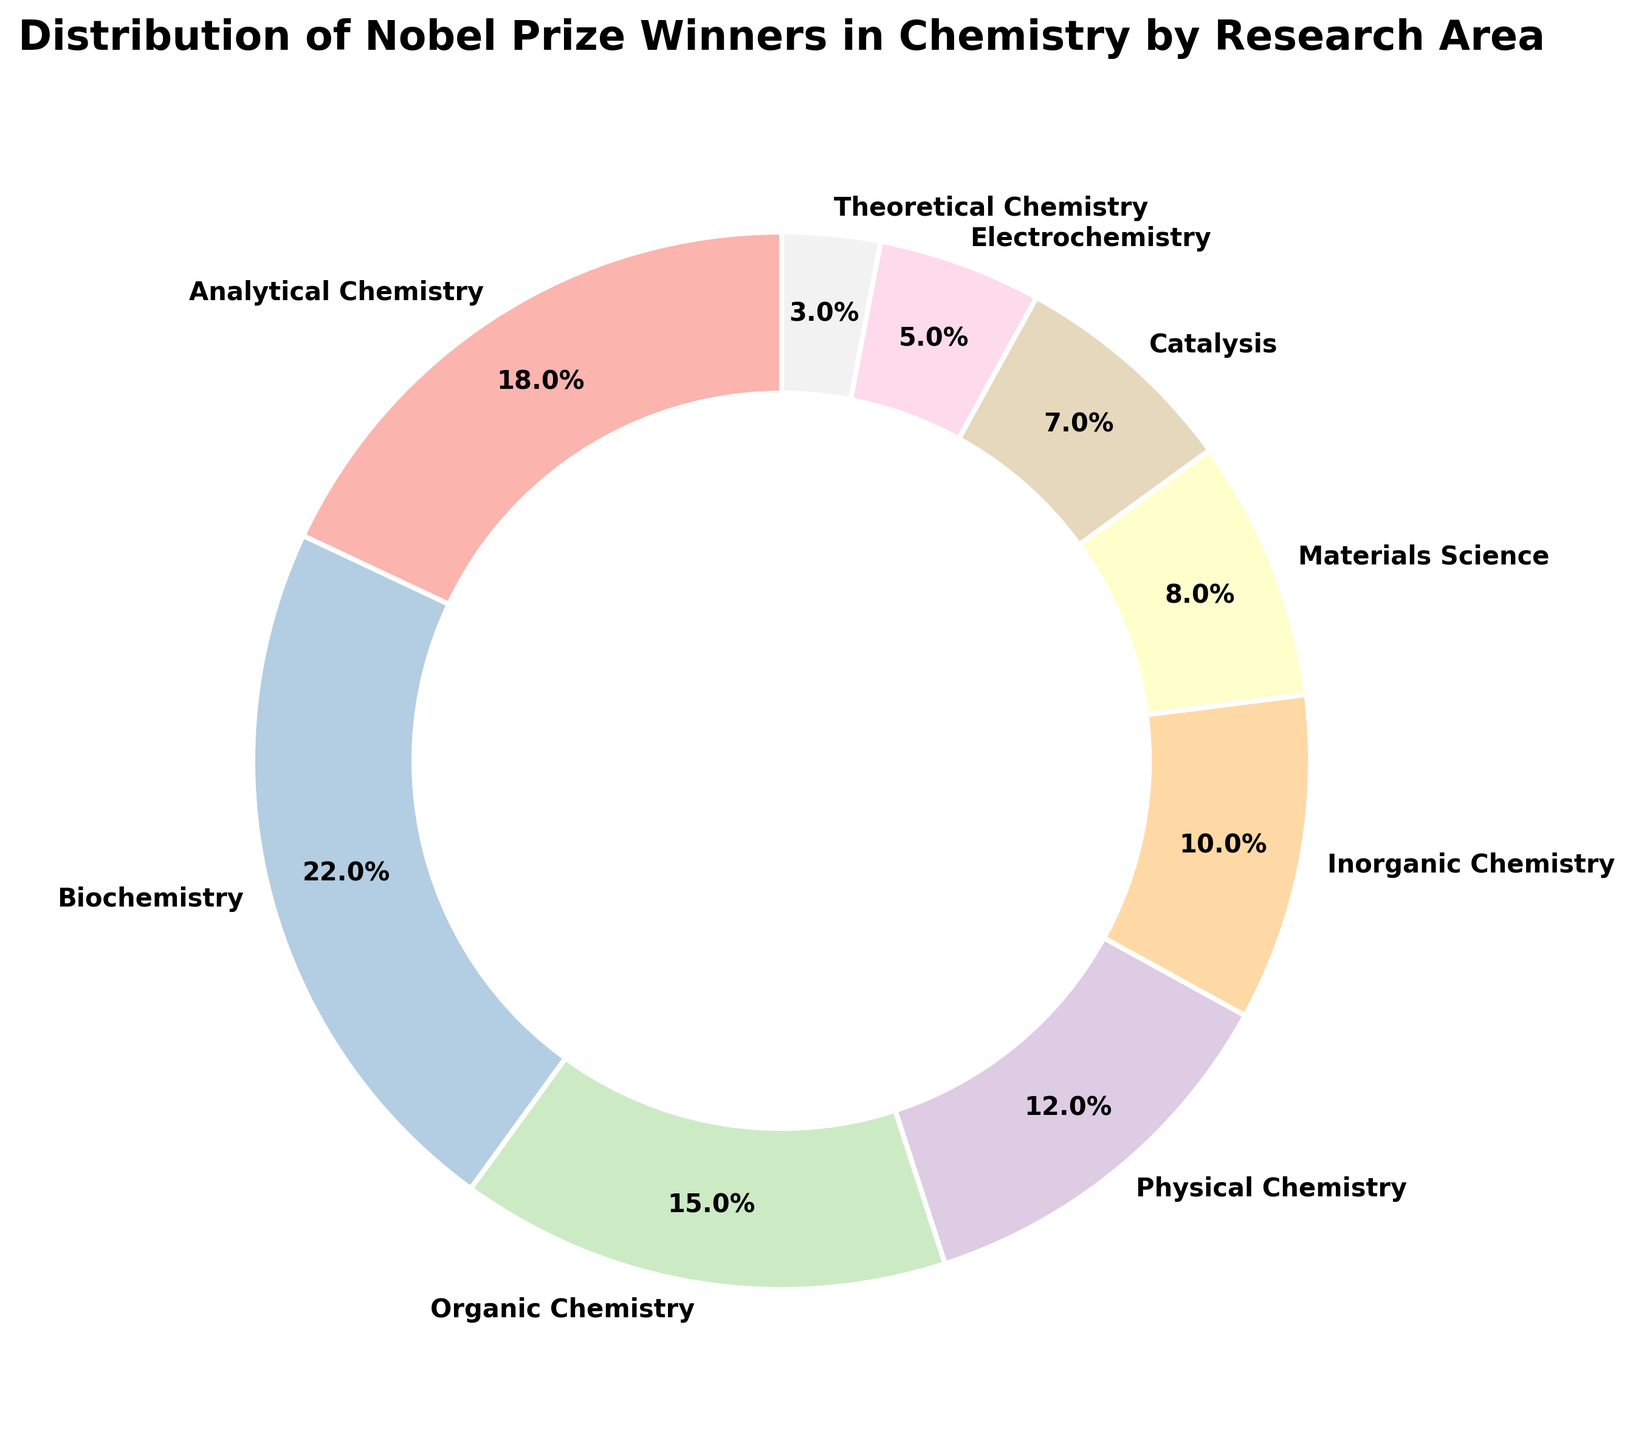What percentage of Nobel Prize winners in Chemistry researched Analytical Chemistry? From the figure, locate the section labeled "Analytical Chemistry." The percentage shown is 18%.
Answer: 18% Which research area has the second highest percentage of Nobel Prize winners? Identify the section with the highest percentage first, which is Biochemistry at 22%. The second highest section following it is Analytical Chemistry at 18%.
Answer: Analytical Chemistry What is the combined percentage of Nobel Prize winners in Biochemistry and Organic Chemistry? Identify the percentages for Biochemistry (22%) and Organic Chemistry (15%). Add these two percentages together: 22% + 15% = 37%.
Answer: 37% How many research areas have a percentage of Nobel Prize winners greater than 10%? Identify the research areas with percentages greater than 10%: Analytical Chemistry (18%), Biochemistry (22%), Organic Chemistry (15%), and Physical Chemistry (12%). Count these areas: 4 areas.
Answer: 4 Which research area has the smallest percentage of Nobel Prize winners? Identify the section with the smallest percentage by comparing all sections. The smallest section is Theoretical Chemistry at 3%.
Answer: Theoretical Chemistry Is the percentage of Nobel Prize winners in Physical Chemistry greater than that in Materials Science? Identify the percentages for Physical Chemistry (12%) and Materials Science (8%). Compare the two: 12% > 8%.
Answer: Yes What is the difference in percentage between Nobel Prize winners in Inorganic Chemistry and those in Electrochemistry? Identify the percentages for Inorganic Chemistry (10%) and Electrochemistry (5%). Subtract the smaller percentage from the larger one: 10% - 5% = 5%.
Answer: 5% What percentage of Nobel Prize winners come from research areas with less than 10% representation? Identify the areas with less than 10%: Materials Science (8%), Catalysis (7%), Electrochemistry (5%), and Theoretical Chemistry (3%). Add these percentages together: 8% + 7% + 5% + 3% = 23%.
Answer: 23% What is the total percentage of Nobel Prize winners in chemistry research areas that specialize in either Analytical Chemistry or Inorganic Chemistry? Identify the percentages for Analytical Chemistry (18%) and Inorganic Chemistry (10%). Add these two percentages together: 18% + 10% = 28%.
Answer: 28% Which research area has a percentage that is half of Organic Chemistry’s percentage? Identify the percentage for Organic Chemistry (15%). Half of 15% is 7.5%. The closest percentage in the figure is Catalysis at 7%.
Answer: Catalysis 